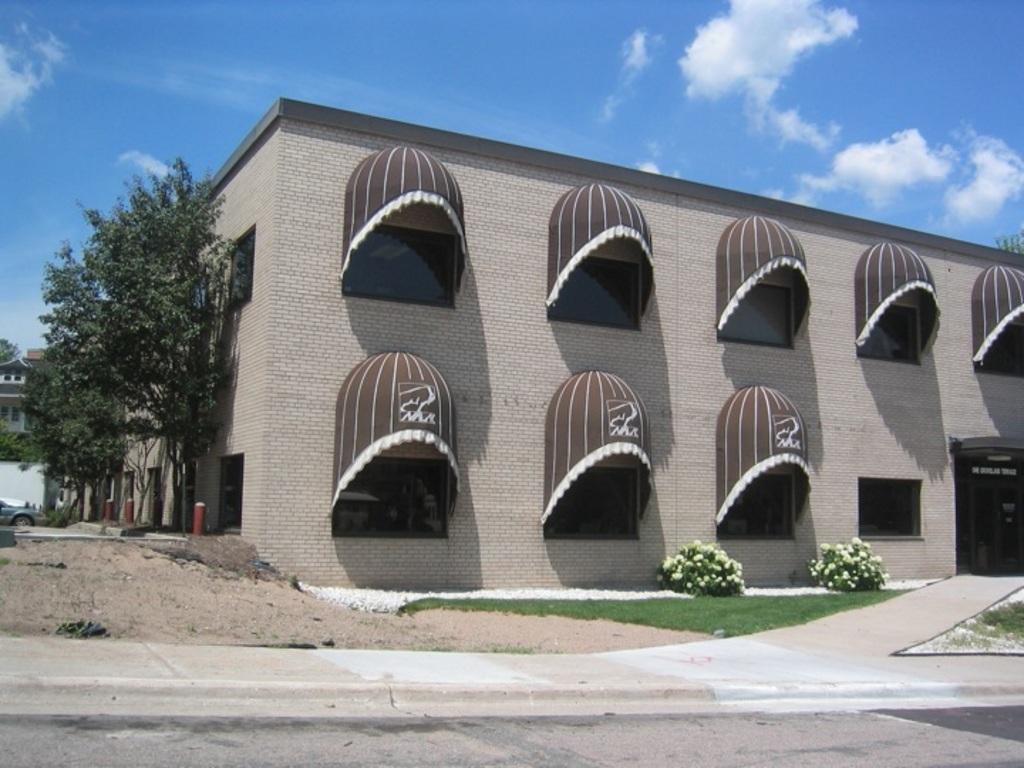How would you summarize this image in a sentence or two? There is a building with glass windows. Near to the windows there are shades. Also there are trees near to the building. Also there are flowering plants. In the front of the building there is a path. In the background there is sky with clouds. 